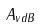Convert formula to latex. <formula><loc_0><loc_0><loc_500><loc_500>A _ { v d B }</formula> 